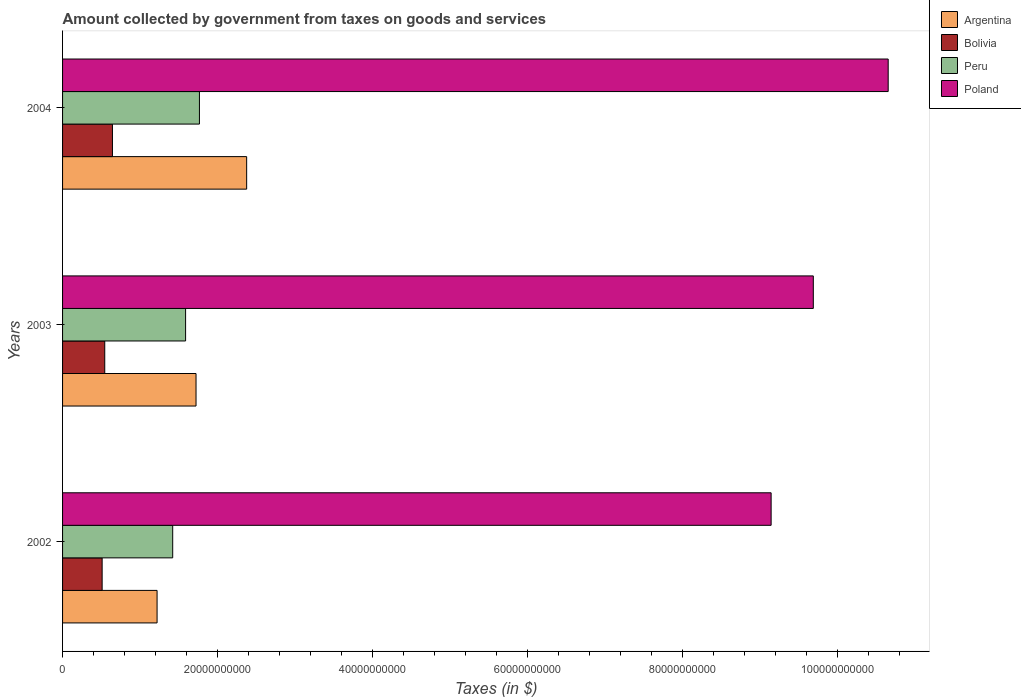How many different coloured bars are there?
Provide a succinct answer. 4. How many groups of bars are there?
Provide a succinct answer. 3. Are the number of bars on each tick of the Y-axis equal?
Offer a very short reply. Yes. How many bars are there on the 1st tick from the top?
Ensure brevity in your answer.  4. How many bars are there on the 2nd tick from the bottom?
Make the answer very short. 4. What is the label of the 3rd group of bars from the top?
Offer a terse response. 2002. What is the amount collected by government from taxes on goods and services in Bolivia in 2004?
Provide a succinct answer. 6.44e+09. Across all years, what is the maximum amount collected by government from taxes on goods and services in Bolivia?
Make the answer very short. 6.44e+09. Across all years, what is the minimum amount collected by government from taxes on goods and services in Argentina?
Give a very brief answer. 1.22e+1. In which year was the amount collected by government from taxes on goods and services in Bolivia maximum?
Provide a short and direct response. 2004. What is the total amount collected by government from taxes on goods and services in Argentina in the graph?
Provide a succinct answer. 5.32e+1. What is the difference between the amount collected by government from taxes on goods and services in Bolivia in 2003 and that in 2004?
Offer a very short reply. -9.93e+08. What is the difference between the amount collected by government from taxes on goods and services in Poland in 2004 and the amount collected by government from taxes on goods and services in Argentina in 2002?
Give a very brief answer. 9.44e+1. What is the average amount collected by government from taxes on goods and services in Peru per year?
Provide a succinct answer. 1.59e+1. In the year 2004, what is the difference between the amount collected by government from taxes on goods and services in Peru and amount collected by government from taxes on goods and services in Argentina?
Keep it short and to the point. -6.10e+09. In how many years, is the amount collected by government from taxes on goods and services in Poland greater than 8000000000 $?
Keep it short and to the point. 3. What is the ratio of the amount collected by government from taxes on goods and services in Peru in 2003 to that in 2004?
Provide a short and direct response. 0.9. Is the amount collected by government from taxes on goods and services in Argentina in 2003 less than that in 2004?
Your response must be concise. Yes. Is the difference between the amount collected by government from taxes on goods and services in Peru in 2002 and 2003 greater than the difference between the amount collected by government from taxes on goods and services in Argentina in 2002 and 2003?
Provide a succinct answer. Yes. What is the difference between the highest and the second highest amount collected by government from taxes on goods and services in Peru?
Offer a very short reply. 1.79e+09. What is the difference between the highest and the lowest amount collected by government from taxes on goods and services in Bolivia?
Make the answer very short. 1.33e+09. In how many years, is the amount collected by government from taxes on goods and services in Peru greater than the average amount collected by government from taxes on goods and services in Peru taken over all years?
Offer a very short reply. 1. Is it the case that in every year, the sum of the amount collected by government from taxes on goods and services in Bolivia and amount collected by government from taxes on goods and services in Argentina is greater than the sum of amount collected by government from taxes on goods and services in Poland and amount collected by government from taxes on goods and services in Peru?
Your answer should be compact. No. What does the 4th bar from the bottom in 2002 represents?
Make the answer very short. Poland. Is it the case that in every year, the sum of the amount collected by government from taxes on goods and services in Peru and amount collected by government from taxes on goods and services in Poland is greater than the amount collected by government from taxes on goods and services in Argentina?
Offer a very short reply. Yes. How many bars are there?
Your answer should be very brief. 12. Are all the bars in the graph horizontal?
Give a very brief answer. Yes. Does the graph contain grids?
Provide a short and direct response. No. What is the title of the graph?
Ensure brevity in your answer.  Amount collected by government from taxes on goods and services. Does "Luxembourg" appear as one of the legend labels in the graph?
Keep it short and to the point. No. What is the label or title of the X-axis?
Provide a short and direct response. Taxes (in $). What is the label or title of the Y-axis?
Your response must be concise. Years. What is the Taxes (in $) of Argentina in 2002?
Ensure brevity in your answer.  1.22e+1. What is the Taxes (in $) in Bolivia in 2002?
Offer a terse response. 5.11e+09. What is the Taxes (in $) of Peru in 2002?
Your response must be concise. 1.42e+1. What is the Taxes (in $) in Poland in 2002?
Provide a short and direct response. 9.15e+1. What is the Taxes (in $) in Argentina in 2003?
Your response must be concise. 1.72e+1. What is the Taxes (in $) of Bolivia in 2003?
Your answer should be very brief. 5.45e+09. What is the Taxes (in $) in Peru in 2003?
Your answer should be very brief. 1.59e+1. What is the Taxes (in $) of Poland in 2003?
Ensure brevity in your answer.  9.69e+1. What is the Taxes (in $) in Argentina in 2004?
Your answer should be compact. 2.38e+1. What is the Taxes (in $) of Bolivia in 2004?
Your answer should be very brief. 6.44e+09. What is the Taxes (in $) of Peru in 2004?
Keep it short and to the point. 1.77e+1. What is the Taxes (in $) in Poland in 2004?
Your answer should be compact. 1.07e+11. Across all years, what is the maximum Taxes (in $) of Argentina?
Offer a very short reply. 2.38e+1. Across all years, what is the maximum Taxes (in $) of Bolivia?
Provide a succinct answer. 6.44e+09. Across all years, what is the maximum Taxes (in $) in Peru?
Provide a short and direct response. 1.77e+1. Across all years, what is the maximum Taxes (in $) of Poland?
Make the answer very short. 1.07e+11. Across all years, what is the minimum Taxes (in $) in Argentina?
Your answer should be very brief. 1.22e+1. Across all years, what is the minimum Taxes (in $) in Bolivia?
Offer a very short reply. 5.11e+09. Across all years, what is the minimum Taxes (in $) of Peru?
Your response must be concise. 1.42e+1. Across all years, what is the minimum Taxes (in $) in Poland?
Offer a terse response. 9.15e+1. What is the total Taxes (in $) in Argentina in the graph?
Your response must be concise. 5.32e+1. What is the total Taxes (in $) in Bolivia in the graph?
Your answer should be very brief. 1.70e+1. What is the total Taxes (in $) of Peru in the graph?
Offer a very short reply. 4.78e+1. What is the total Taxes (in $) of Poland in the graph?
Provide a short and direct response. 2.95e+11. What is the difference between the Taxes (in $) of Argentina in 2002 and that in 2003?
Ensure brevity in your answer.  -5.03e+09. What is the difference between the Taxes (in $) of Bolivia in 2002 and that in 2003?
Your answer should be very brief. -3.37e+08. What is the difference between the Taxes (in $) of Peru in 2002 and that in 2003?
Ensure brevity in your answer.  -1.67e+09. What is the difference between the Taxes (in $) in Poland in 2002 and that in 2003?
Give a very brief answer. -5.45e+09. What is the difference between the Taxes (in $) in Argentina in 2002 and that in 2004?
Keep it short and to the point. -1.16e+1. What is the difference between the Taxes (in $) in Bolivia in 2002 and that in 2004?
Keep it short and to the point. -1.33e+09. What is the difference between the Taxes (in $) in Peru in 2002 and that in 2004?
Offer a terse response. -3.45e+09. What is the difference between the Taxes (in $) in Poland in 2002 and that in 2004?
Your response must be concise. -1.51e+1. What is the difference between the Taxes (in $) in Argentina in 2003 and that in 2004?
Offer a very short reply. -6.54e+09. What is the difference between the Taxes (in $) in Bolivia in 2003 and that in 2004?
Offer a terse response. -9.93e+08. What is the difference between the Taxes (in $) in Peru in 2003 and that in 2004?
Provide a short and direct response. -1.79e+09. What is the difference between the Taxes (in $) of Poland in 2003 and that in 2004?
Your answer should be compact. -9.67e+09. What is the difference between the Taxes (in $) of Argentina in 2002 and the Taxes (in $) of Bolivia in 2003?
Your answer should be compact. 6.75e+09. What is the difference between the Taxes (in $) of Argentina in 2002 and the Taxes (in $) of Peru in 2003?
Offer a terse response. -3.68e+09. What is the difference between the Taxes (in $) in Argentina in 2002 and the Taxes (in $) in Poland in 2003?
Your answer should be very brief. -8.47e+1. What is the difference between the Taxes (in $) in Bolivia in 2002 and the Taxes (in $) in Peru in 2003?
Offer a terse response. -1.08e+1. What is the difference between the Taxes (in $) of Bolivia in 2002 and the Taxes (in $) of Poland in 2003?
Ensure brevity in your answer.  -9.18e+1. What is the difference between the Taxes (in $) in Peru in 2002 and the Taxes (in $) in Poland in 2003?
Give a very brief answer. -8.27e+1. What is the difference between the Taxes (in $) of Argentina in 2002 and the Taxes (in $) of Bolivia in 2004?
Keep it short and to the point. 5.76e+09. What is the difference between the Taxes (in $) of Argentina in 2002 and the Taxes (in $) of Peru in 2004?
Offer a very short reply. -5.47e+09. What is the difference between the Taxes (in $) of Argentina in 2002 and the Taxes (in $) of Poland in 2004?
Your answer should be very brief. -9.44e+1. What is the difference between the Taxes (in $) in Bolivia in 2002 and the Taxes (in $) in Peru in 2004?
Your response must be concise. -1.26e+1. What is the difference between the Taxes (in $) of Bolivia in 2002 and the Taxes (in $) of Poland in 2004?
Give a very brief answer. -1.01e+11. What is the difference between the Taxes (in $) of Peru in 2002 and the Taxes (in $) of Poland in 2004?
Your response must be concise. -9.24e+1. What is the difference between the Taxes (in $) in Argentina in 2003 and the Taxes (in $) in Bolivia in 2004?
Offer a terse response. 1.08e+1. What is the difference between the Taxes (in $) in Argentina in 2003 and the Taxes (in $) in Peru in 2004?
Ensure brevity in your answer.  -4.39e+08. What is the difference between the Taxes (in $) of Argentina in 2003 and the Taxes (in $) of Poland in 2004?
Your answer should be compact. -8.94e+1. What is the difference between the Taxes (in $) in Bolivia in 2003 and the Taxes (in $) in Peru in 2004?
Your answer should be very brief. -1.22e+1. What is the difference between the Taxes (in $) in Bolivia in 2003 and the Taxes (in $) in Poland in 2004?
Keep it short and to the point. -1.01e+11. What is the difference between the Taxes (in $) in Peru in 2003 and the Taxes (in $) in Poland in 2004?
Offer a very short reply. -9.07e+1. What is the average Taxes (in $) of Argentina per year?
Your answer should be very brief. 1.77e+1. What is the average Taxes (in $) in Bolivia per year?
Ensure brevity in your answer.  5.67e+09. What is the average Taxes (in $) in Peru per year?
Your answer should be compact. 1.59e+1. What is the average Taxes (in $) of Poland per year?
Keep it short and to the point. 9.83e+1. In the year 2002, what is the difference between the Taxes (in $) in Argentina and Taxes (in $) in Bolivia?
Make the answer very short. 7.09e+09. In the year 2002, what is the difference between the Taxes (in $) in Argentina and Taxes (in $) in Peru?
Make the answer very short. -2.02e+09. In the year 2002, what is the difference between the Taxes (in $) in Argentina and Taxes (in $) in Poland?
Provide a short and direct response. -7.93e+1. In the year 2002, what is the difference between the Taxes (in $) of Bolivia and Taxes (in $) of Peru?
Your answer should be compact. -9.11e+09. In the year 2002, what is the difference between the Taxes (in $) of Bolivia and Taxes (in $) of Poland?
Your answer should be very brief. -8.64e+1. In the year 2002, what is the difference between the Taxes (in $) of Peru and Taxes (in $) of Poland?
Provide a succinct answer. -7.73e+1. In the year 2003, what is the difference between the Taxes (in $) of Argentina and Taxes (in $) of Bolivia?
Give a very brief answer. 1.18e+1. In the year 2003, what is the difference between the Taxes (in $) of Argentina and Taxes (in $) of Peru?
Ensure brevity in your answer.  1.35e+09. In the year 2003, what is the difference between the Taxes (in $) of Argentina and Taxes (in $) of Poland?
Give a very brief answer. -7.97e+1. In the year 2003, what is the difference between the Taxes (in $) in Bolivia and Taxes (in $) in Peru?
Your answer should be compact. -1.04e+1. In the year 2003, what is the difference between the Taxes (in $) in Bolivia and Taxes (in $) in Poland?
Ensure brevity in your answer.  -9.15e+1. In the year 2003, what is the difference between the Taxes (in $) of Peru and Taxes (in $) of Poland?
Your answer should be very brief. -8.10e+1. In the year 2004, what is the difference between the Taxes (in $) of Argentina and Taxes (in $) of Bolivia?
Your response must be concise. 1.73e+1. In the year 2004, what is the difference between the Taxes (in $) of Argentina and Taxes (in $) of Peru?
Keep it short and to the point. 6.10e+09. In the year 2004, what is the difference between the Taxes (in $) in Argentina and Taxes (in $) in Poland?
Offer a very short reply. -8.28e+1. In the year 2004, what is the difference between the Taxes (in $) in Bolivia and Taxes (in $) in Peru?
Your response must be concise. -1.12e+1. In the year 2004, what is the difference between the Taxes (in $) of Bolivia and Taxes (in $) of Poland?
Provide a succinct answer. -1.00e+11. In the year 2004, what is the difference between the Taxes (in $) in Peru and Taxes (in $) in Poland?
Offer a very short reply. -8.89e+1. What is the ratio of the Taxes (in $) of Argentina in 2002 to that in 2003?
Keep it short and to the point. 0.71. What is the ratio of the Taxes (in $) of Bolivia in 2002 to that in 2003?
Your response must be concise. 0.94. What is the ratio of the Taxes (in $) of Peru in 2002 to that in 2003?
Offer a terse response. 0.9. What is the ratio of the Taxes (in $) of Poland in 2002 to that in 2003?
Your answer should be compact. 0.94. What is the ratio of the Taxes (in $) of Argentina in 2002 to that in 2004?
Give a very brief answer. 0.51. What is the ratio of the Taxes (in $) in Bolivia in 2002 to that in 2004?
Provide a succinct answer. 0.79. What is the ratio of the Taxes (in $) in Peru in 2002 to that in 2004?
Your answer should be very brief. 0.8. What is the ratio of the Taxes (in $) in Poland in 2002 to that in 2004?
Provide a short and direct response. 0.86. What is the ratio of the Taxes (in $) of Argentina in 2003 to that in 2004?
Keep it short and to the point. 0.72. What is the ratio of the Taxes (in $) in Bolivia in 2003 to that in 2004?
Provide a short and direct response. 0.85. What is the ratio of the Taxes (in $) of Peru in 2003 to that in 2004?
Provide a succinct answer. 0.9. What is the ratio of the Taxes (in $) of Poland in 2003 to that in 2004?
Provide a succinct answer. 0.91. What is the difference between the highest and the second highest Taxes (in $) of Argentina?
Keep it short and to the point. 6.54e+09. What is the difference between the highest and the second highest Taxes (in $) of Bolivia?
Ensure brevity in your answer.  9.93e+08. What is the difference between the highest and the second highest Taxes (in $) of Peru?
Your answer should be compact. 1.79e+09. What is the difference between the highest and the second highest Taxes (in $) of Poland?
Provide a short and direct response. 9.67e+09. What is the difference between the highest and the lowest Taxes (in $) of Argentina?
Your response must be concise. 1.16e+1. What is the difference between the highest and the lowest Taxes (in $) in Bolivia?
Provide a short and direct response. 1.33e+09. What is the difference between the highest and the lowest Taxes (in $) of Peru?
Your answer should be very brief. 3.45e+09. What is the difference between the highest and the lowest Taxes (in $) in Poland?
Offer a terse response. 1.51e+1. 